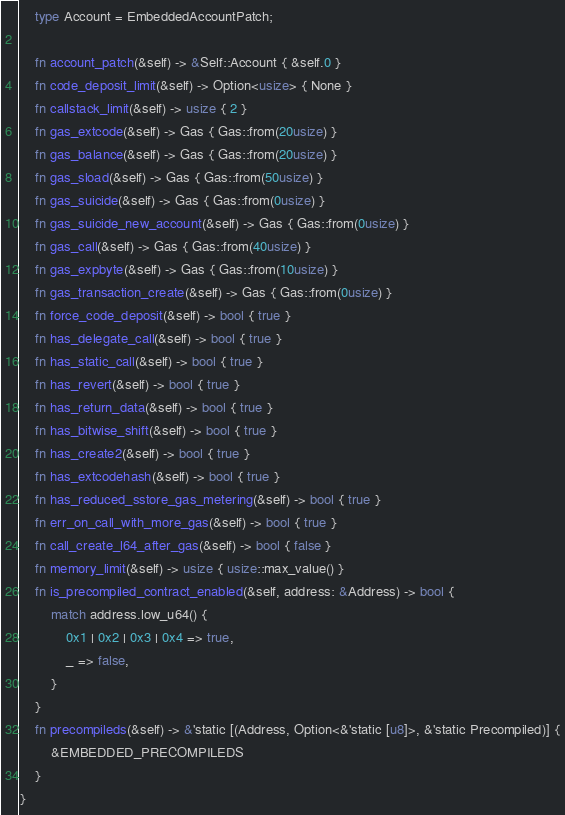<code> <loc_0><loc_0><loc_500><loc_500><_Rust_>    type Account = EmbeddedAccountPatch;

    fn account_patch(&self) -> &Self::Account { &self.0 }
    fn code_deposit_limit(&self) -> Option<usize> { None }
    fn callstack_limit(&self) -> usize { 2 }
    fn gas_extcode(&self) -> Gas { Gas::from(20usize) }
    fn gas_balance(&self) -> Gas { Gas::from(20usize) }
    fn gas_sload(&self) -> Gas { Gas::from(50usize) }
    fn gas_suicide(&self) -> Gas { Gas::from(0usize) }
    fn gas_suicide_new_account(&self) -> Gas { Gas::from(0usize) }
    fn gas_call(&self) -> Gas { Gas::from(40usize) }
    fn gas_expbyte(&self) -> Gas { Gas::from(10usize) }
    fn gas_transaction_create(&self) -> Gas { Gas::from(0usize) }
    fn force_code_deposit(&self) -> bool { true }
    fn has_delegate_call(&self) -> bool { true }
    fn has_static_call(&self) -> bool { true }
    fn has_revert(&self) -> bool { true }
    fn has_return_data(&self) -> bool { true }
    fn has_bitwise_shift(&self) -> bool { true }
    fn has_create2(&self) -> bool { true }
    fn has_extcodehash(&self) -> bool { true }
    fn has_reduced_sstore_gas_metering(&self) -> bool { true }
    fn err_on_call_with_more_gas(&self) -> bool { true }
    fn call_create_l64_after_gas(&self) -> bool { false }
    fn memory_limit(&self) -> usize { usize::max_value() }
    fn is_precompiled_contract_enabled(&self, address: &Address) -> bool {
        match address.low_u64() {
            0x1 | 0x2 | 0x3 | 0x4 => true,
            _ => false,
        }
    }
    fn precompileds(&self) -> &'static [(Address, Option<&'static [u8]>, &'static Precompiled)] {
        &EMBEDDED_PRECOMPILEDS
    }
}
</code> 